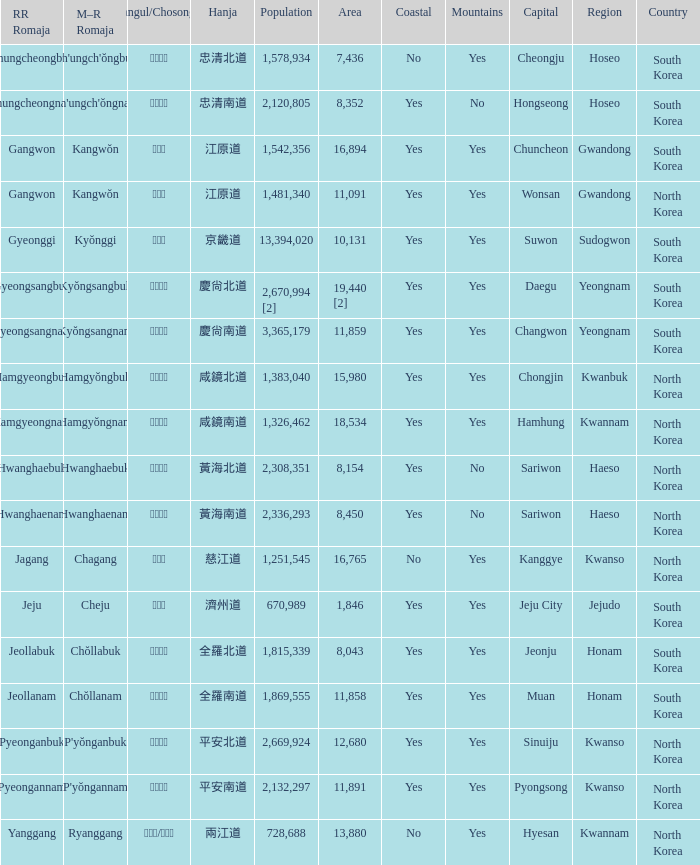What is the M-R Romaja for the province having a capital of Cheongju? Ch'ungch'ŏngbuk. 